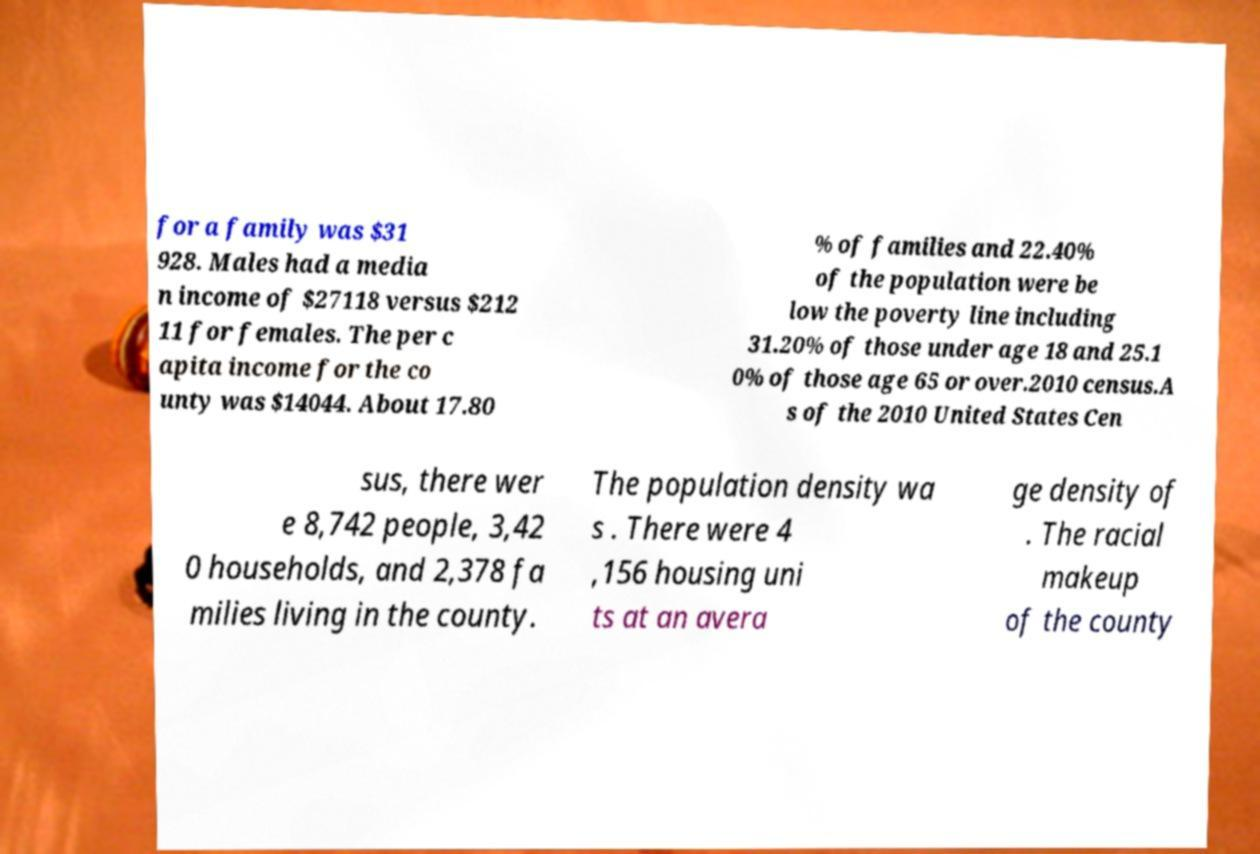What messages or text are displayed in this image? I need them in a readable, typed format. for a family was $31 928. Males had a media n income of $27118 versus $212 11 for females. The per c apita income for the co unty was $14044. About 17.80 % of families and 22.40% of the population were be low the poverty line including 31.20% of those under age 18 and 25.1 0% of those age 65 or over.2010 census.A s of the 2010 United States Cen sus, there wer e 8,742 people, 3,42 0 households, and 2,378 fa milies living in the county. The population density wa s . There were 4 ,156 housing uni ts at an avera ge density of . The racial makeup of the county 